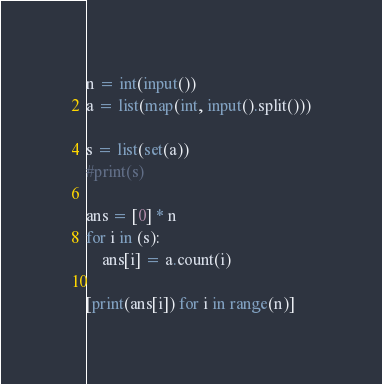<code> <loc_0><loc_0><loc_500><loc_500><_Python_>n = int(input())
a = list(map(int, input().split()))

s = list(set(a))
#print(s)

ans = [0] * n
for i in (s):
    ans[i] = a.count(i)

[print(ans[i]) for i in range(n)]</code> 